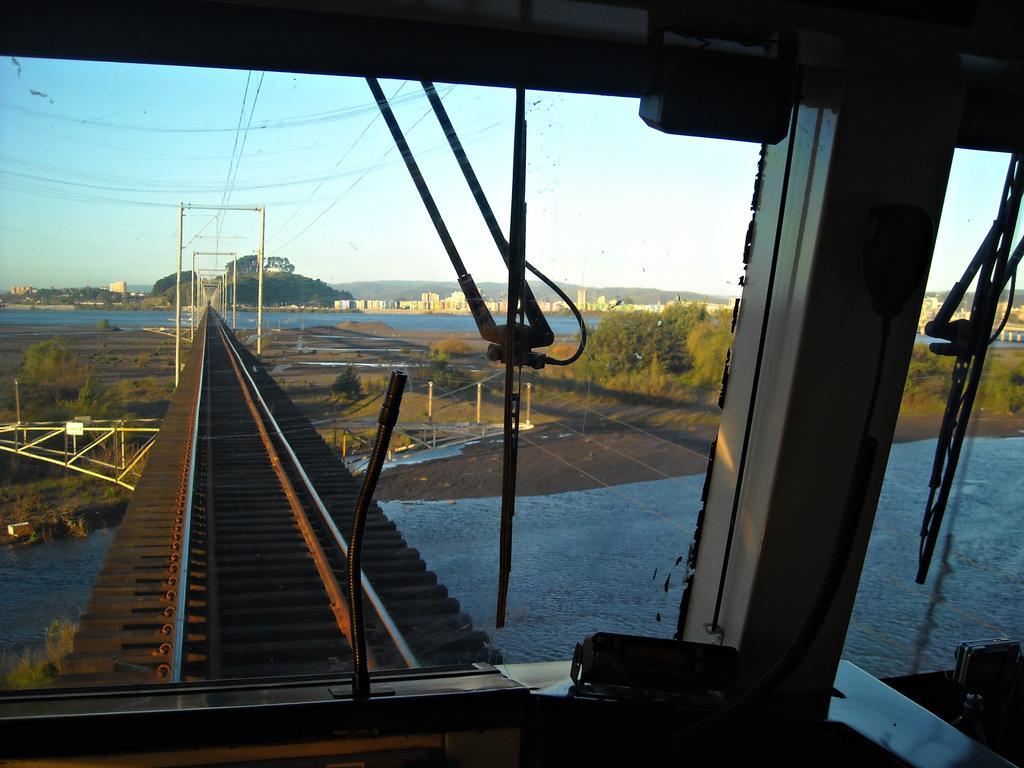How would you summarize this image in a sentence or two? This image is clicked from a train. In the front, we can see a track. At the bottom, there is water. On the right, there are trees. It looks like a bridge. At the top, there is sky. In the background, there are buildings. 